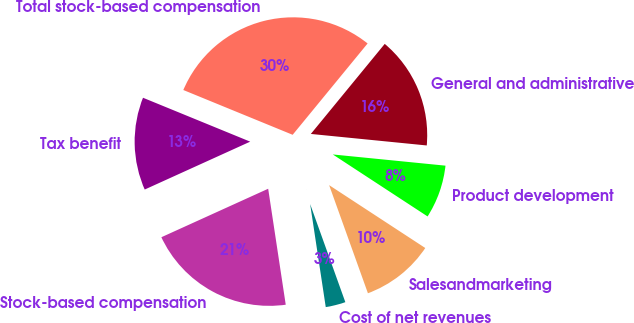<chart> <loc_0><loc_0><loc_500><loc_500><pie_chart><fcel>Cost of net revenues<fcel>Salesandmarketing<fcel>Product development<fcel>General and administrative<fcel>Total stock-based compensation<fcel>Tax benefit<fcel>Stock-based compensation<nl><fcel>3.09%<fcel>10.3%<fcel>7.64%<fcel>15.64%<fcel>29.75%<fcel>12.97%<fcel>20.61%<nl></chart> 